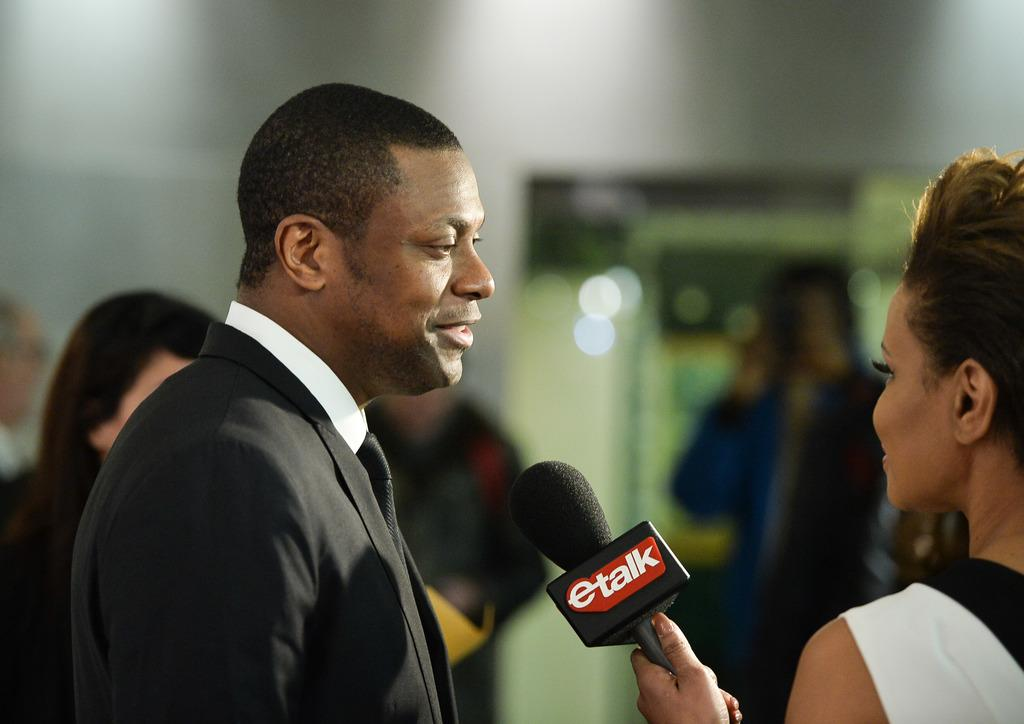What is the man in the image wearing? The man is wearing a suit in the image. What is the man doing in the image? The man is talking in the image. Who else is present in the image? There is a woman in the image. What is the woman doing in the image? The woman is standing and holding a microphone in the image. Can you describe the background of the image? There are people visible in the background of the image. How many chickens can be seen in the image? There are no chickens present in the image. What type of door is visible in the image? There is no door visible in the image. 